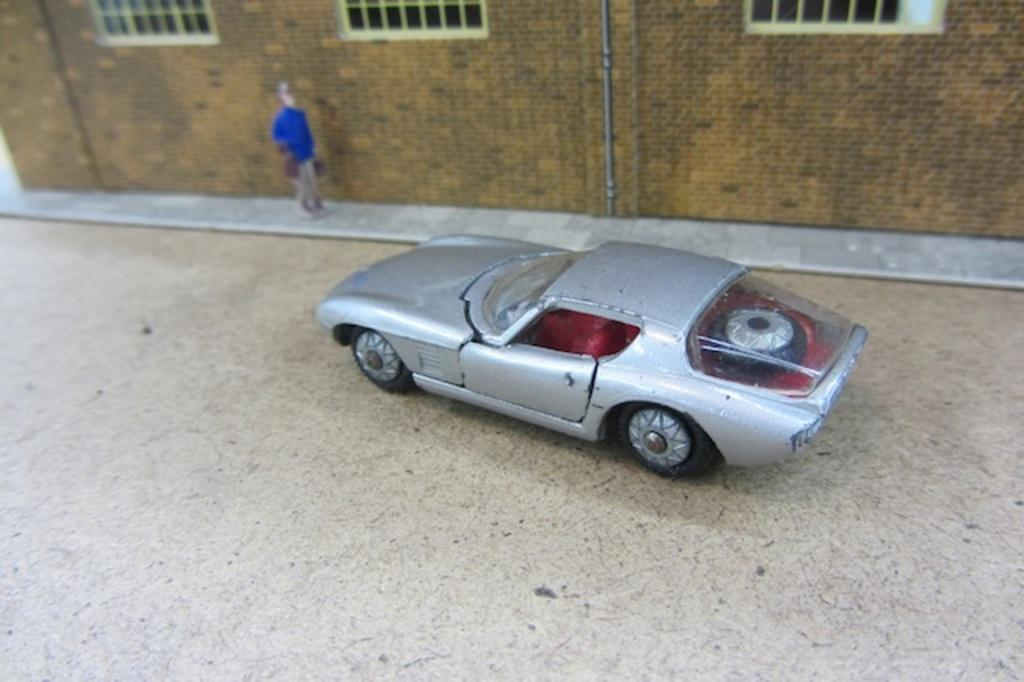What object is on the floor in the image? There is a toy car on the floor. Can you describe the person in the image? There is a person in the image, but no specific details are provided about their appearance or actions. What can be seen in the background of the image? There is a building visible in the background of the image. How many deer can be seen grazing in the image? There are no deer present in the image. What type of machine is being operated by the person in the image? There is no machine visible in the image, and no information is provided about the person's actions. 